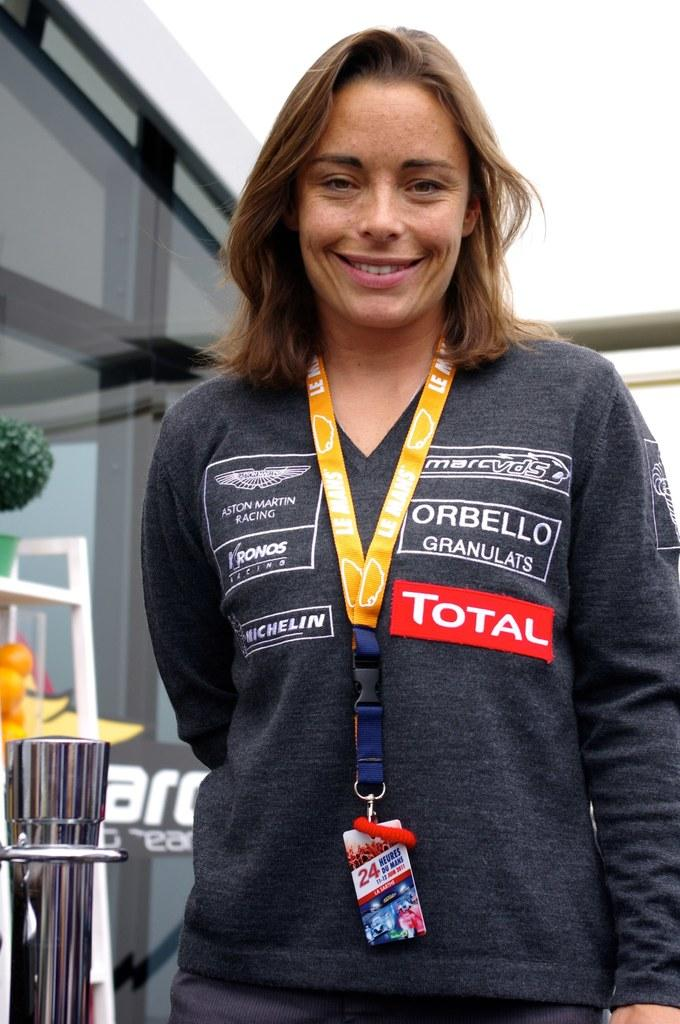<image>
Provide a brief description of the given image. a lady that has the word total on her shirt 